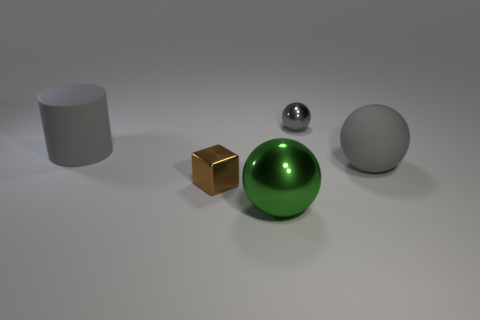Are there any big gray spheres that have the same material as the green sphere?
Provide a short and direct response. No. What is the size of the metal sphere that is the same color as the large cylinder?
Offer a terse response. Small. There is a shiny ball that is in front of the tiny brown object that is to the left of the tiny gray shiny ball; what is its color?
Make the answer very short. Green. Does the rubber cylinder have the same size as the green metal ball?
Provide a succinct answer. Yes. How many balls are either small gray metal things or large green metallic objects?
Provide a short and direct response. 2. There is a gray metal sphere that is on the right side of the tiny brown block; what number of small objects are to the right of it?
Offer a terse response. 0. Do the big green metallic object and the brown object have the same shape?
Your answer should be compact. No. What size is the other matte thing that is the same shape as the green object?
Your response must be concise. Large. What is the shape of the gray rubber object on the right side of the large rubber object that is to the left of the gray metal thing?
Ensure brevity in your answer.  Sphere. What size is the brown metal object?
Ensure brevity in your answer.  Small. 